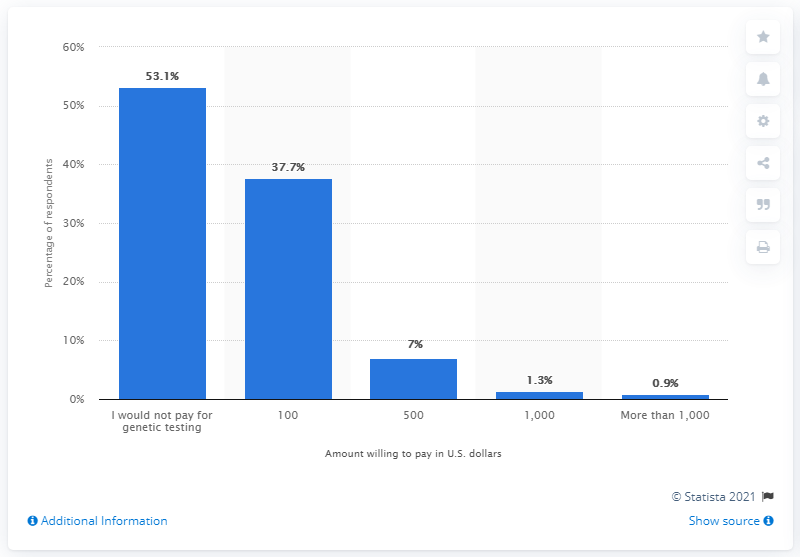Can you tell me how many people would pay more than $500 for genetic testing? The chart indicates that 7 percent of respondents would pay $500, 1.3 percent would pay $1,000, and 0.9 percent are willing to pay more than $1,000 for genetic testing. 